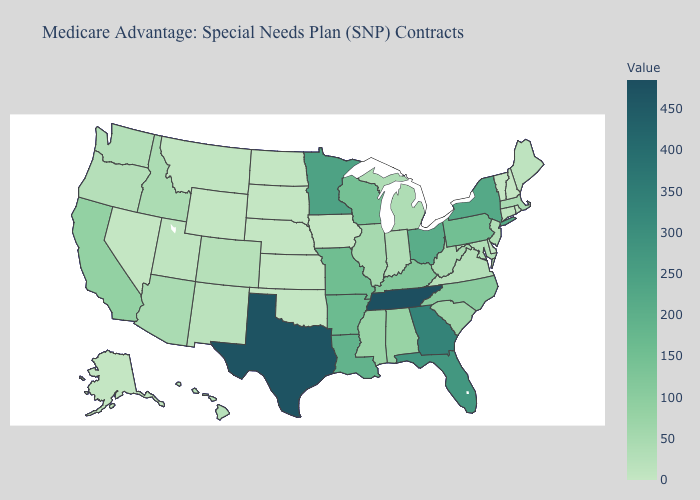Does Kansas have the lowest value in the USA?
Write a very short answer. Yes. Among the states that border Vermont , does Massachusetts have the highest value?
Keep it brief. No. Which states have the highest value in the USA?
Give a very brief answer. Tennessee. Which states have the lowest value in the Northeast?
Write a very short answer. New Hampshire, Rhode Island, Vermont. Does North Dakota have a higher value than Texas?
Short answer required. No. Does the map have missing data?
Quick response, please. No. Among the states that border Kansas , does Colorado have the highest value?
Concise answer only. No. 